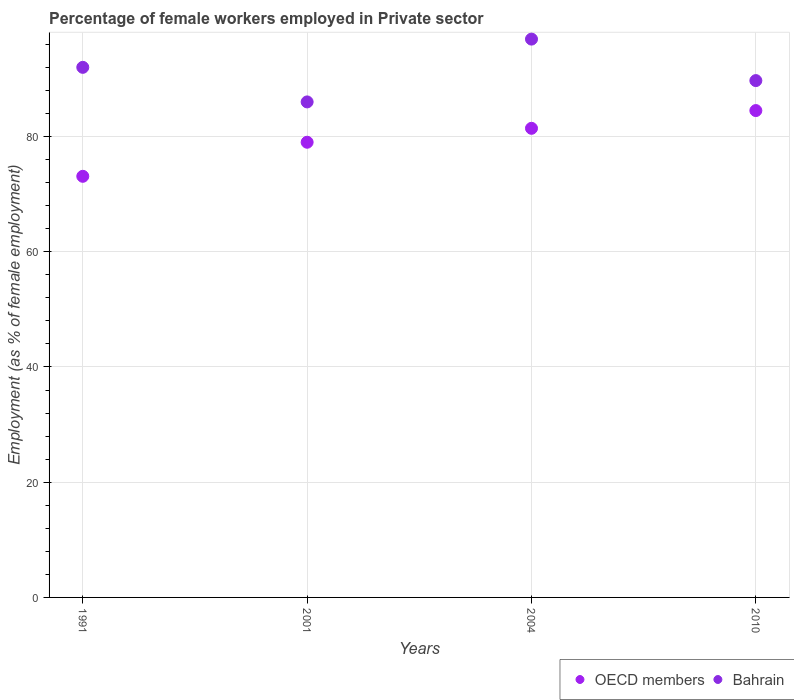How many different coloured dotlines are there?
Make the answer very short. 2. Is the number of dotlines equal to the number of legend labels?
Provide a short and direct response. Yes. What is the percentage of females employed in Private sector in OECD members in 2004?
Your answer should be very brief. 81.42. Across all years, what is the maximum percentage of females employed in Private sector in Bahrain?
Ensure brevity in your answer.  96.9. Across all years, what is the minimum percentage of females employed in Private sector in OECD members?
Your answer should be very brief. 73.09. In which year was the percentage of females employed in Private sector in Bahrain maximum?
Provide a succinct answer. 2004. In which year was the percentage of females employed in Private sector in Bahrain minimum?
Make the answer very short. 2001. What is the total percentage of females employed in Private sector in OECD members in the graph?
Your answer should be compact. 318. What is the difference between the percentage of females employed in Private sector in OECD members in 1991 and that in 2001?
Offer a very short reply. -5.91. What is the difference between the percentage of females employed in Private sector in Bahrain in 2001 and the percentage of females employed in Private sector in OECD members in 2010?
Keep it short and to the point. 1.5. What is the average percentage of females employed in Private sector in Bahrain per year?
Keep it short and to the point. 91.15. In the year 2001, what is the difference between the percentage of females employed in Private sector in OECD members and percentage of females employed in Private sector in Bahrain?
Your answer should be compact. -7. What is the ratio of the percentage of females employed in Private sector in OECD members in 1991 to that in 2001?
Your answer should be very brief. 0.93. Is the difference between the percentage of females employed in Private sector in OECD members in 2001 and 2010 greater than the difference between the percentage of females employed in Private sector in Bahrain in 2001 and 2010?
Make the answer very short. No. What is the difference between the highest and the second highest percentage of females employed in Private sector in OECD members?
Your answer should be compact. 3.08. What is the difference between the highest and the lowest percentage of females employed in Private sector in OECD members?
Provide a succinct answer. 11.41. Is the sum of the percentage of females employed in Private sector in Bahrain in 1991 and 2010 greater than the maximum percentage of females employed in Private sector in OECD members across all years?
Your response must be concise. Yes. Does the percentage of females employed in Private sector in OECD members monotonically increase over the years?
Ensure brevity in your answer.  Yes. How many dotlines are there?
Your response must be concise. 2. How many years are there in the graph?
Provide a succinct answer. 4. What is the difference between two consecutive major ticks on the Y-axis?
Your response must be concise. 20. Are the values on the major ticks of Y-axis written in scientific E-notation?
Provide a succinct answer. No. Does the graph contain any zero values?
Keep it short and to the point. No. Where does the legend appear in the graph?
Ensure brevity in your answer.  Bottom right. How many legend labels are there?
Provide a succinct answer. 2. What is the title of the graph?
Your response must be concise. Percentage of female workers employed in Private sector. What is the label or title of the X-axis?
Ensure brevity in your answer.  Years. What is the label or title of the Y-axis?
Ensure brevity in your answer.  Employment (as % of female employment). What is the Employment (as % of female employment) of OECD members in 1991?
Offer a very short reply. 73.09. What is the Employment (as % of female employment) of Bahrain in 1991?
Offer a terse response. 92. What is the Employment (as % of female employment) in OECD members in 2001?
Give a very brief answer. 79. What is the Employment (as % of female employment) in OECD members in 2004?
Ensure brevity in your answer.  81.42. What is the Employment (as % of female employment) of Bahrain in 2004?
Your response must be concise. 96.9. What is the Employment (as % of female employment) in OECD members in 2010?
Your answer should be compact. 84.5. What is the Employment (as % of female employment) of Bahrain in 2010?
Make the answer very short. 89.7. Across all years, what is the maximum Employment (as % of female employment) in OECD members?
Keep it short and to the point. 84.5. Across all years, what is the maximum Employment (as % of female employment) in Bahrain?
Your response must be concise. 96.9. Across all years, what is the minimum Employment (as % of female employment) of OECD members?
Provide a short and direct response. 73.09. Across all years, what is the minimum Employment (as % of female employment) in Bahrain?
Your response must be concise. 86. What is the total Employment (as % of female employment) of OECD members in the graph?
Ensure brevity in your answer.  318. What is the total Employment (as % of female employment) of Bahrain in the graph?
Ensure brevity in your answer.  364.6. What is the difference between the Employment (as % of female employment) in OECD members in 1991 and that in 2001?
Ensure brevity in your answer.  -5.91. What is the difference between the Employment (as % of female employment) of Bahrain in 1991 and that in 2001?
Keep it short and to the point. 6. What is the difference between the Employment (as % of female employment) of OECD members in 1991 and that in 2004?
Make the answer very short. -8.33. What is the difference between the Employment (as % of female employment) in OECD members in 1991 and that in 2010?
Give a very brief answer. -11.41. What is the difference between the Employment (as % of female employment) of Bahrain in 1991 and that in 2010?
Give a very brief answer. 2.3. What is the difference between the Employment (as % of female employment) of OECD members in 2001 and that in 2004?
Offer a very short reply. -2.42. What is the difference between the Employment (as % of female employment) in OECD members in 2001 and that in 2010?
Your answer should be very brief. -5.5. What is the difference between the Employment (as % of female employment) in OECD members in 2004 and that in 2010?
Give a very brief answer. -3.08. What is the difference between the Employment (as % of female employment) of OECD members in 1991 and the Employment (as % of female employment) of Bahrain in 2001?
Your answer should be very brief. -12.91. What is the difference between the Employment (as % of female employment) of OECD members in 1991 and the Employment (as % of female employment) of Bahrain in 2004?
Give a very brief answer. -23.81. What is the difference between the Employment (as % of female employment) in OECD members in 1991 and the Employment (as % of female employment) in Bahrain in 2010?
Offer a very short reply. -16.61. What is the difference between the Employment (as % of female employment) in OECD members in 2001 and the Employment (as % of female employment) in Bahrain in 2004?
Make the answer very short. -17.9. What is the difference between the Employment (as % of female employment) of OECD members in 2001 and the Employment (as % of female employment) of Bahrain in 2010?
Provide a short and direct response. -10.7. What is the difference between the Employment (as % of female employment) in OECD members in 2004 and the Employment (as % of female employment) in Bahrain in 2010?
Keep it short and to the point. -8.28. What is the average Employment (as % of female employment) of OECD members per year?
Make the answer very short. 79.5. What is the average Employment (as % of female employment) of Bahrain per year?
Make the answer very short. 91.15. In the year 1991, what is the difference between the Employment (as % of female employment) in OECD members and Employment (as % of female employment) in Bahrain?
Keep it short and to the point. -18.91. In the year 2001, what is the difference between the Employment (as % of female employment) of OECD members and Employment (as % of female employment) of Bahrain?
Make the answer very short. -7. In the year 2004, what is the difference between the Employment (as % of female employment) in OECD members and Employment (as % of female employment) in Bahrain?
Offer a terse response. -15.48. In the year 2010, what is the difference between the Employment (as % of female employment) of OECD members and Employment (as % of female employment) of Bahrain?
Provide a succinct answer. -5.2. What is the ratio of the Employment (as % of female employment) in OECD members in 1991 to that in 2001?
Offer a very short reply. 0.93. What is the ratio of the Employment (as % of female employment) in Bahrain in 1991 to that in 2001?
Your answer should be very brief. 1.07. What is the ratio of the Employment (as % of female employment) in OECD members in 1991 to that in 2004?
Your response must be concise. 0.9. What is the ratio of the Employment (as % of female employment) in Bahrain in 1991 to that in 2004?
Ensure brevity in your answer.  0.95. What is the ratio of the Employment (as % of female employment) in OECD members in 1991 to that in 2010?
Provide a short and direct response. 0.86. What is the ratio of the Employment (as % of female employment) in Bahrain in 1991 to that in 2010?
Ensure brevity in your answer.  1.03. What is the ratio of the Employment (as % of female employment) in OECD members in 2001 to that in 2004?
Make the answer very short. 0.97. What is the ratio of the Employment (as % of female employment) in Bahrain in 2001 to that in 2004?
Offer a very short reply. 0.89. What is the ratio of the Employment (as % of female employment) of OECD members in 2001 to that in 2010?
Offer a very short reply. 0.93. What is the ratio of the Employment (as % of female employment) in Bahrain in 2001 to that in 2010?
Provide a succinct answer. 0.96. What is the ratio of the Employment (as % of female employment) in OECD members in 2004 to that in 2010?
Ensure brevity in your answer.  0.96. What is the ratio of the Employment (as % of female employment) in Bahrain in 2004 to that in 2010?
Offer a terse response. 1.08. What is the difference between the highest and the second highest Employment (as % of female employment) of OECD members?
Your answer should be very brief. 3.08. What is the difference between the highest and the second highest Employment (as % of female employment) of Bahrain?
Your answer should be very brief. 4.9. What is the difference between the highest and the lowest Employment (as % of female employment) in OECD members?
Keep it short and to the point. 11.41. 